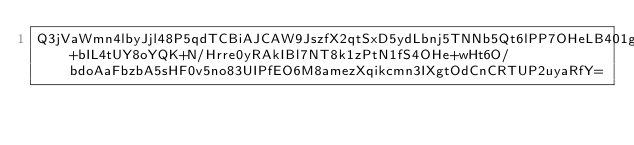<code> <loc_0><loc_0><loc_500><loc_500><_SML_>Q3jVaWmn4lbyJjl48P5qdTCBiAJCAW9JszfX2qtSxD5ydLbnj5TNNb5Qt6lPP7OHeLB401gYTJ0znHHOltn94SIYH7jBG+bIL4tUY8oYQK+N/Hrre0yRAkIBl7NT8k1zPtN1fS4OHe+wHt6O/bdoAaFbzbA5sHF0v5no83UIPfEO6M8amezXqikcmn3IXgtOdCnCRTUP2uyaRfY=</code> 